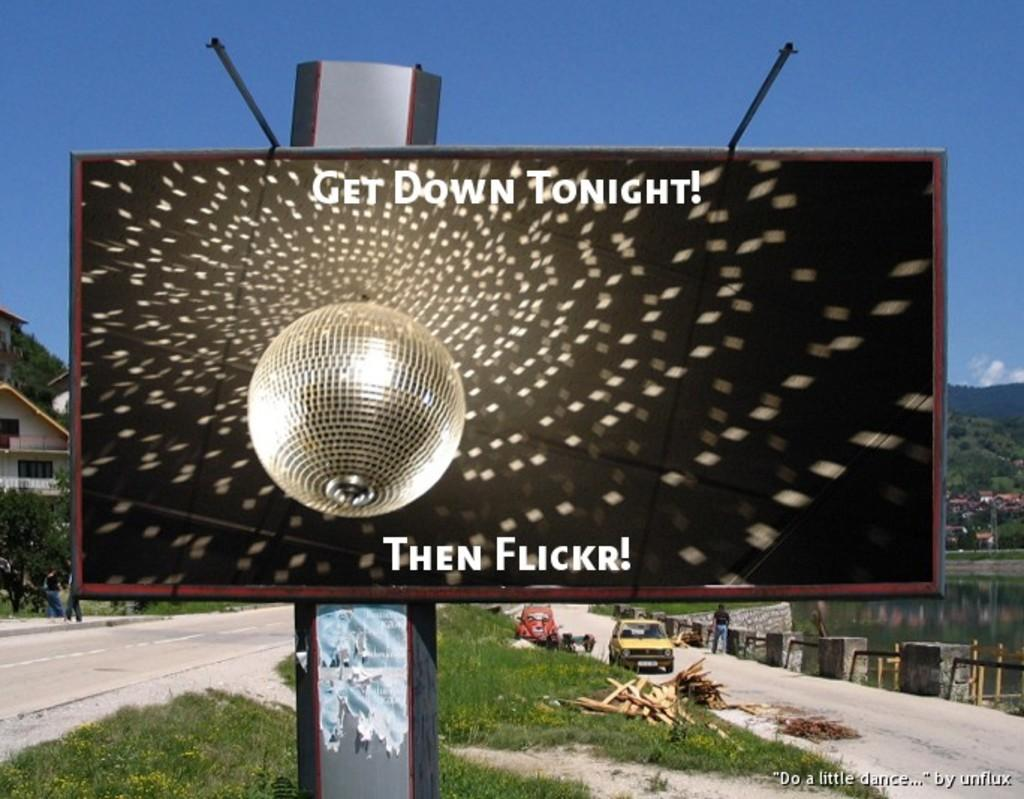<image>
Create a compact narrative representing the image presented. A billboard is advertising Flickr using the disco ball and lights. 